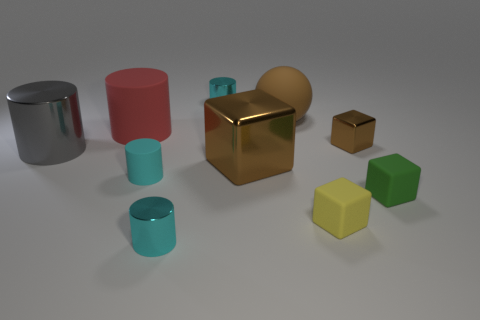There is a small object that is the same color as the big metallic cube; what shape is it?
Provide a succinct answer. Cube. Are there the same number of small yellow things behind the big gray metallic cylinder and rubber cubes on the left side of the big ball?
Your answer should be very brief. Yes. There is a small brown metallic thing; does it have the same shape as the shiny object that is in front of the yellow object?
Provide a short and direct response. No. What number of other things are there of the same material as the large block
Give a very brief answer. 4. Are there any red rubber cylinders to the left of the red thing?
Keep it short and to the point. No. There is a red rubber cylinder; is it the same size as the cyan shiny cylinder in front of the small green cube?
Make the answer very short. No. There is a small block that is behind the brown metal block that is left of the brown matte thing; what color is it?
Offer a very short reply. Brown. Is the brown sphere the same size as the green block?
Your answer should be very brief. No. There is a thing that is left of the brown ball and behind the big matte cylinder; what color is it?
Your answer should be compact. Cyan. The red object is what size?
Provide a short and direct response. Large. 